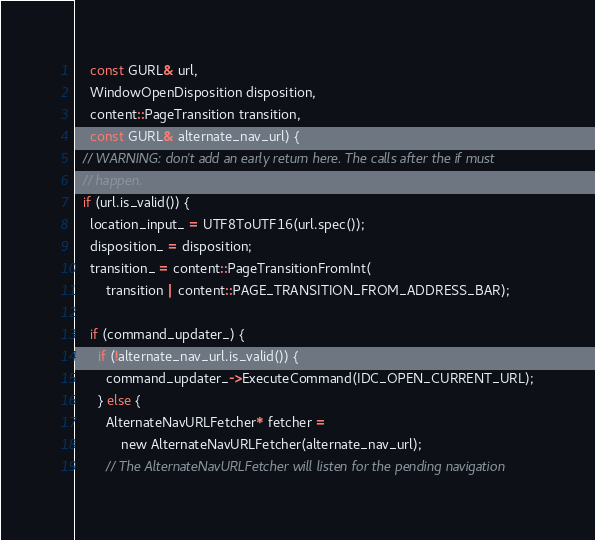<code> <loc_0><loc_0><loc_500><loc_500><_ObjectiveC_>    const GURL& url,
    WindowOpenDisposition disposition,
    content::PageTransition transition,
    const GURL& alternate_nav_url) {
  // WARNING: don't add an early return here. The calls after the if must
  // happen.
  if (url.is_valid()) {
    location_input_ = UTF8ToUTF16(url.spec());
    disposition_ = disposition;
    transition_ = content::PageTransitionFromInt(
        transition | content::PAGE_TRANSITION_FROM_ADDRESS_BAR);

    if (command_updater_) {
      if (!alternate_nav_url.is_valid()) {
        command_updater_->ExecuteCommand(IDC_OPEN_CURRENT_URL);
      } else {
        AlternateNavURLFetcher* fetcher =
            new AlternateNavURLFetcher(alternate_nav_url);
        // The AlternateNavURLFetcher will listen for the pending navigation</code> 